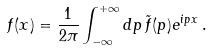<formula> <loc_0><loc_0><loc_500><loc_500>f ( x ) = \frac { 1 } { 2 \pi } \int _ { - \infty } ^ { + \infty } d p \, \tilde { f } ( p ) e ^ { i p x } \, .</formula> 